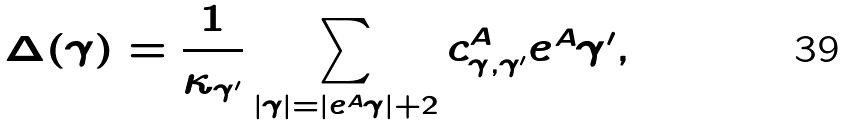Convert formula to latex. <formula><loc_0><loc_0><loc_500><loc_500>\Delta ( \gamma ) = \frac { 1 } { \kappa _ { \gamma ^ { \prime } } } \sum _ { | \gamma | = | e ^ { A } \gamma | + 2 } c ^ { A } _ { \gamma , \gamma ^ { \prime } } e ^ { A } \gamma ^ { \prime } ,</formula> 